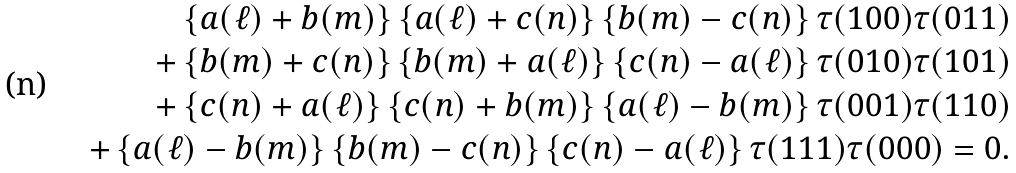<formula> <loc_0><loc_0><loc_500><loc_500>\left \{ a ( \ell ) + b ( m ) \right \} \left \{ a ( \ell ) + c ( n ) \right \} \left \{ b ( m ) - c ( n ) \right \} \tau ( 1 0 0 ) \tau ( 0 1 1 ) \\ + \left \{ b ( m ) + c ( n ) \right \} \left \{ b ( m ) + a ( \ell ) \right \} \left \{ c ( n ) - a ( \ell ) \right \} \tau ( 0 1 0 ) \tau ( 1 0 1 ) \\ + \left \{ c ( n ) + a ( \ell ) \right \} \left \{ c ( n ) + b ( m ) \right \} \left \{ a ( \ell ) - b ( m ) \right \} \tau ( 0 0 1 ) \tau ( 1 1 0 ) \\ + \left \{ a ( \ell ) - b ( m ) \right \} \left \{ b ( m ) - c ( n ) \right \} \left \{ c ( n ) - a ( \ell ) \right \} \tau ( 1 1 1 ) \tau ( 0 0 0 ) = 0 .</formula> 